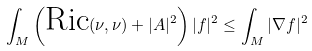Convert formula to latex. <formula><loc_0><loc_0><loc_500><loc_500>\int _ { M } \left ( \text {Ric} ( \nu , \nu ) + | A | ^ { 2 } \right ) | f | ^ { 2 } \leq \int _ { M } | \nabla f | ^ { 2 }</formula> 